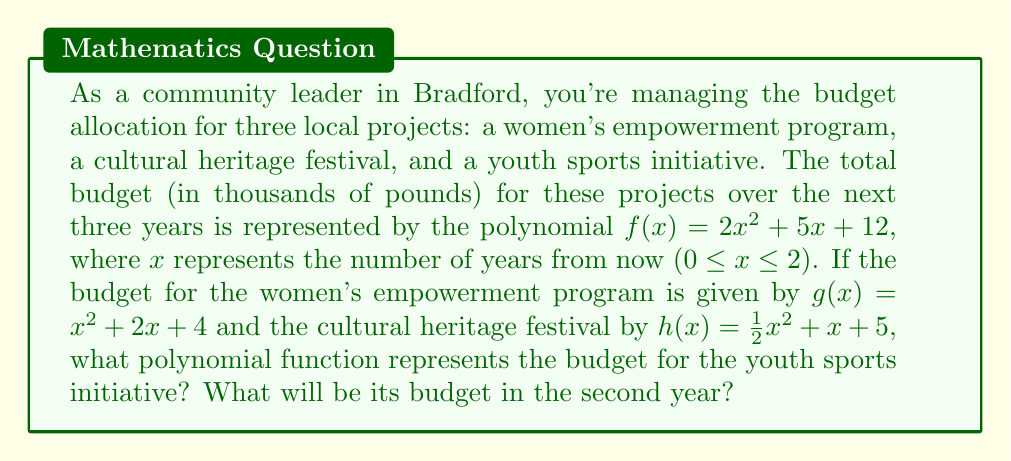Help me with this question. Let's approach this step-by-step:

1) We know that the total budget is represented by $f(x) = 2x^2 + 5x + 12$

2) The women's empowerment program budget is $g(x) = x^2 + 2x + 4$

3) The cultural heritage festival budget is $h(x) = \frac{1}{2}x^2 + x + 5$

4) Let's call the youth sports initiative budget $i(x)$

5) Since these three programs make up the total budget, we can write:
   $f(x) = g(x) + h(x) + i(x)$

6) Substituting the known functions:
   $2x^2 + 5x + 12 = (x^2 + 2x + 4) + (\frac{1}{2}x^2 + x + 5) + i(x)$

7) Simplifying the right side:
   $2x^2 + 5x + 12 = \frac{3}{2}x^2 + 3x + 9 + i(x)$

8) Subtracting the known terms from both sides:
   $\frac{1}{2}x^2 + 2x + 3 = i(x)$

9) Therefore, the polynomial function for the youth sports initiative is:
   $i(x) = \frac{1}{2}x^2 + 2x + 3$

10) To find the budget in the second year, we substitute $x = 2$ into $i(x)$:
    $i(2) = \frac{1}{2}(2)^2 + 2(2) + 3 = 2 + 4 + 3 = 9$

Therefore, the budget for the youth sports initiative in the second year will be 9 thousand pounds, or £9,000.
Answer: $i(x) = \frac{1}{2}x^2 + 2x + 3$; £9,000 